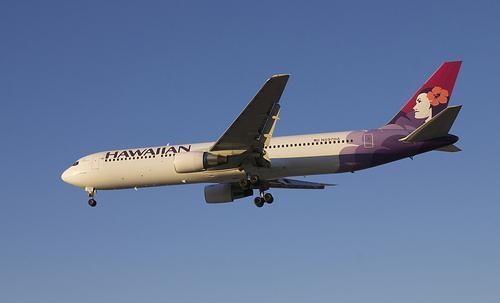How many planes are in this photo?
Give a very brief answer. 1. 